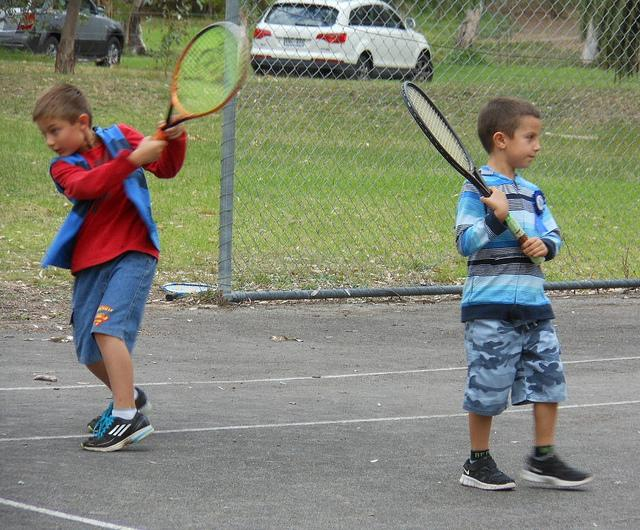What is the first name of the boy in the red's favorite hero? superman 